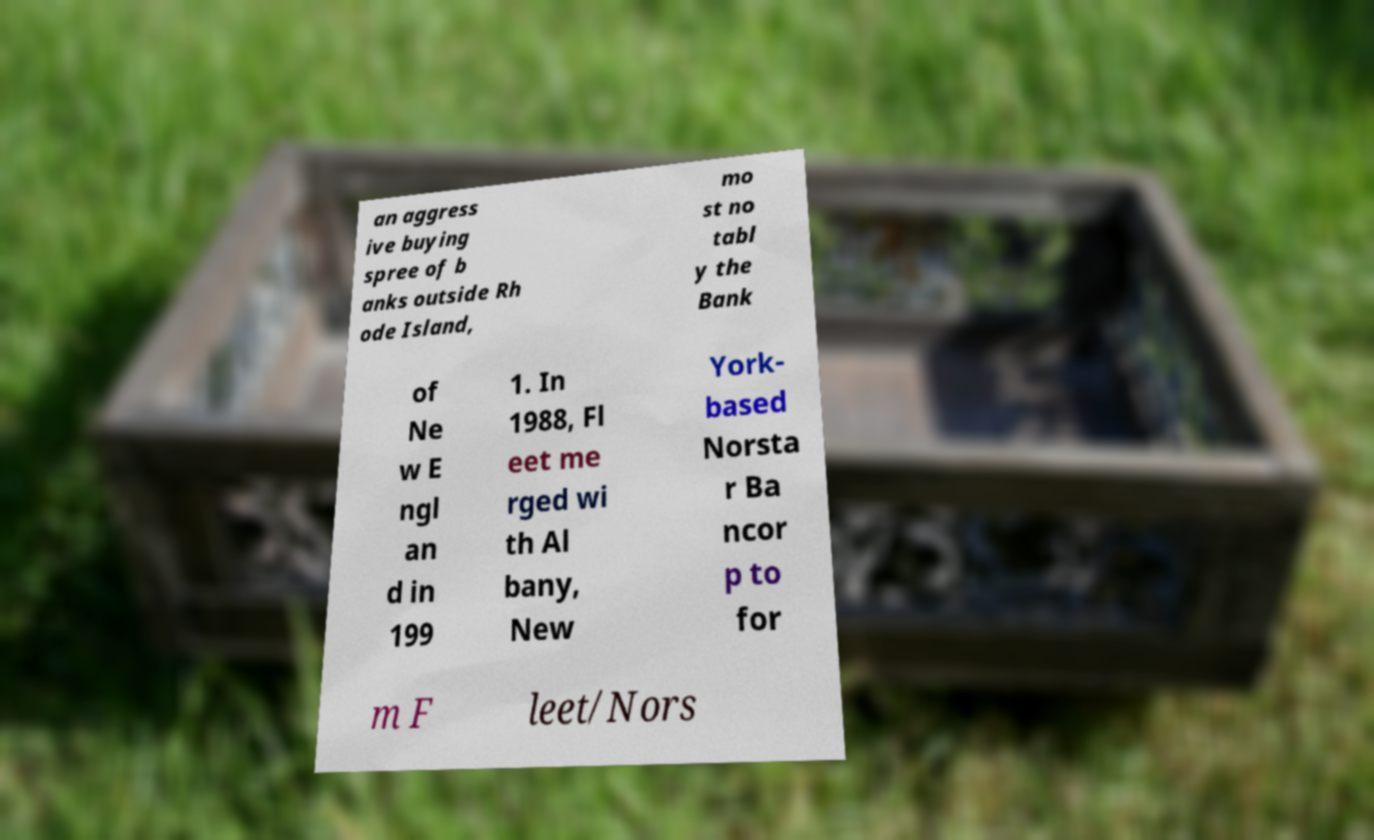Can you accurately transcribe the text from the provided image for me? an aggress ive buying spree of b anks outside Rh ode Island, mo st no tabl y the Bank of Ne w E ngl an d in 199 1. In 1988, Fl eet me rged wi th Al bany, New York- based Norsta r Ba ncor p to for m F leet/Nors 